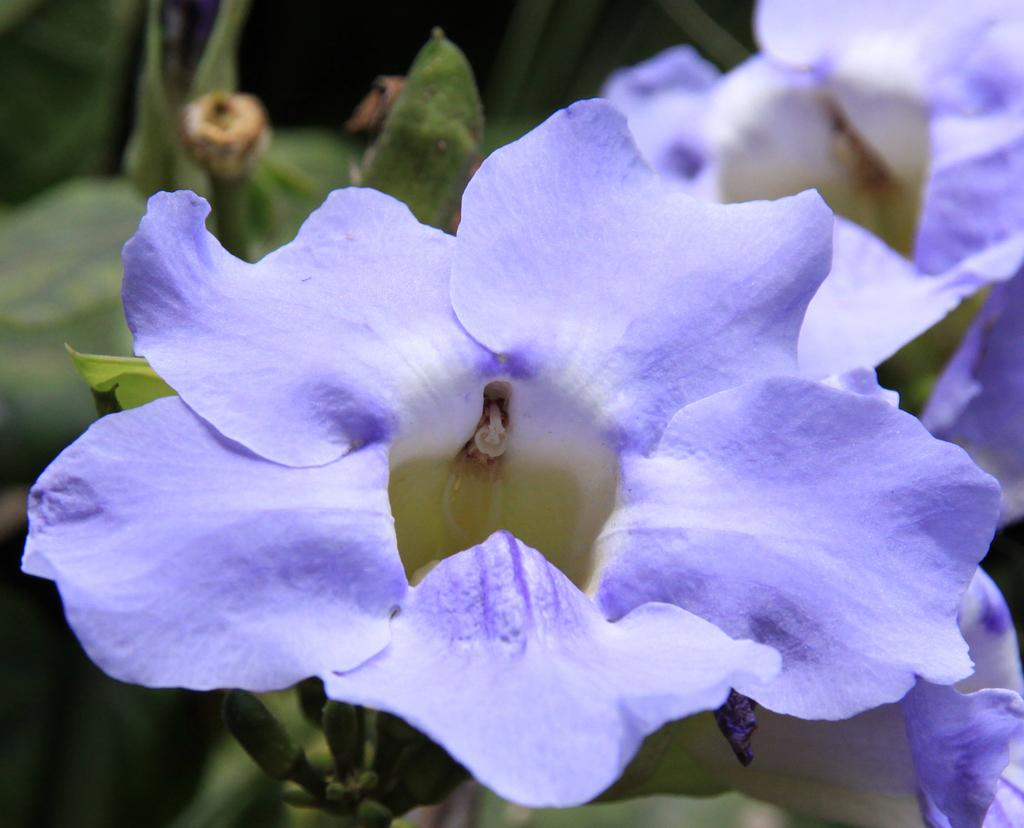What type of plants are in the image? There are ground morning glory flower plants in the image. What type of drum can be seen in the image? There is no drum present in the image; it features ground morning glory flower plants. How many lizards are visible on the sweater in the image? There is no sweater or lizards present in the image. 